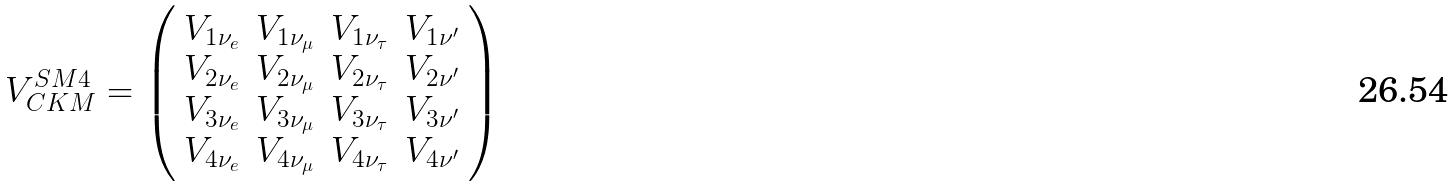Convert formula to latex. <formula><loc_0><loc_0><loc_500><loc_500>V _ { C K M } ^ { S M 4 } = \left ( \begin{array} { l c r r } { { V _ { 1 \nu _ { e } } } } & { { V _ { 1 \nu _ { \mu } } } } & { { V _ { 1 \nu _ { \tau } } } } & { { V _ { 1 \nu ^ { \prime } } } } \\ { { V _ { 2 \nu _ { e } } } } & { { V _ { 2 \nu _ { \mu } } } } & { { V _ { 2 \nu _ { \tau } } } } & { { { V _ { 2 \nu ^ { \prime } } } } } \\ { { V _ { 3 \nu _ { e } } } } & { { V _ { 3 \nu _ { \mu } } } } & { { V _ { 3 \nu _ { \tau } } } } & { { V _ { 3 \nu ^ { \prime } } } } \\ { { V _ { 4 \nu _ { e } } } } & { { V _ { 4 \nu _ { \mu } } } } & { { V _ { 4 \nu _ { \tau } } } } & { { V _ { 4 \nu ^ { \prime } } } } \end{array} \right )</formula> 